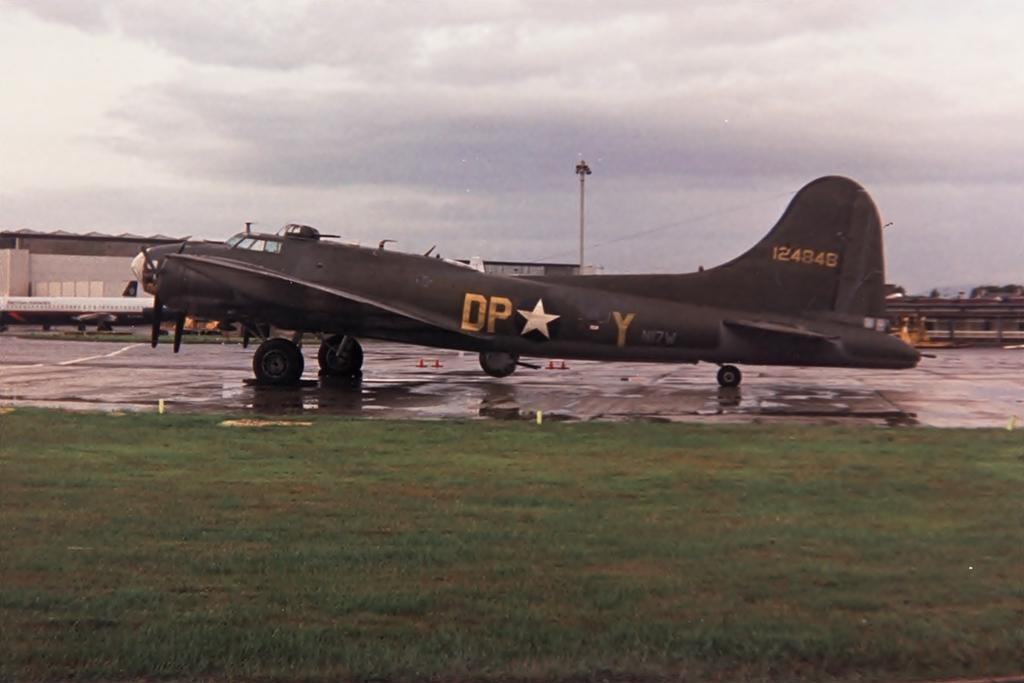<image>
Write a terse but informative summary of the picture. A parked military plane with id number 124848. 